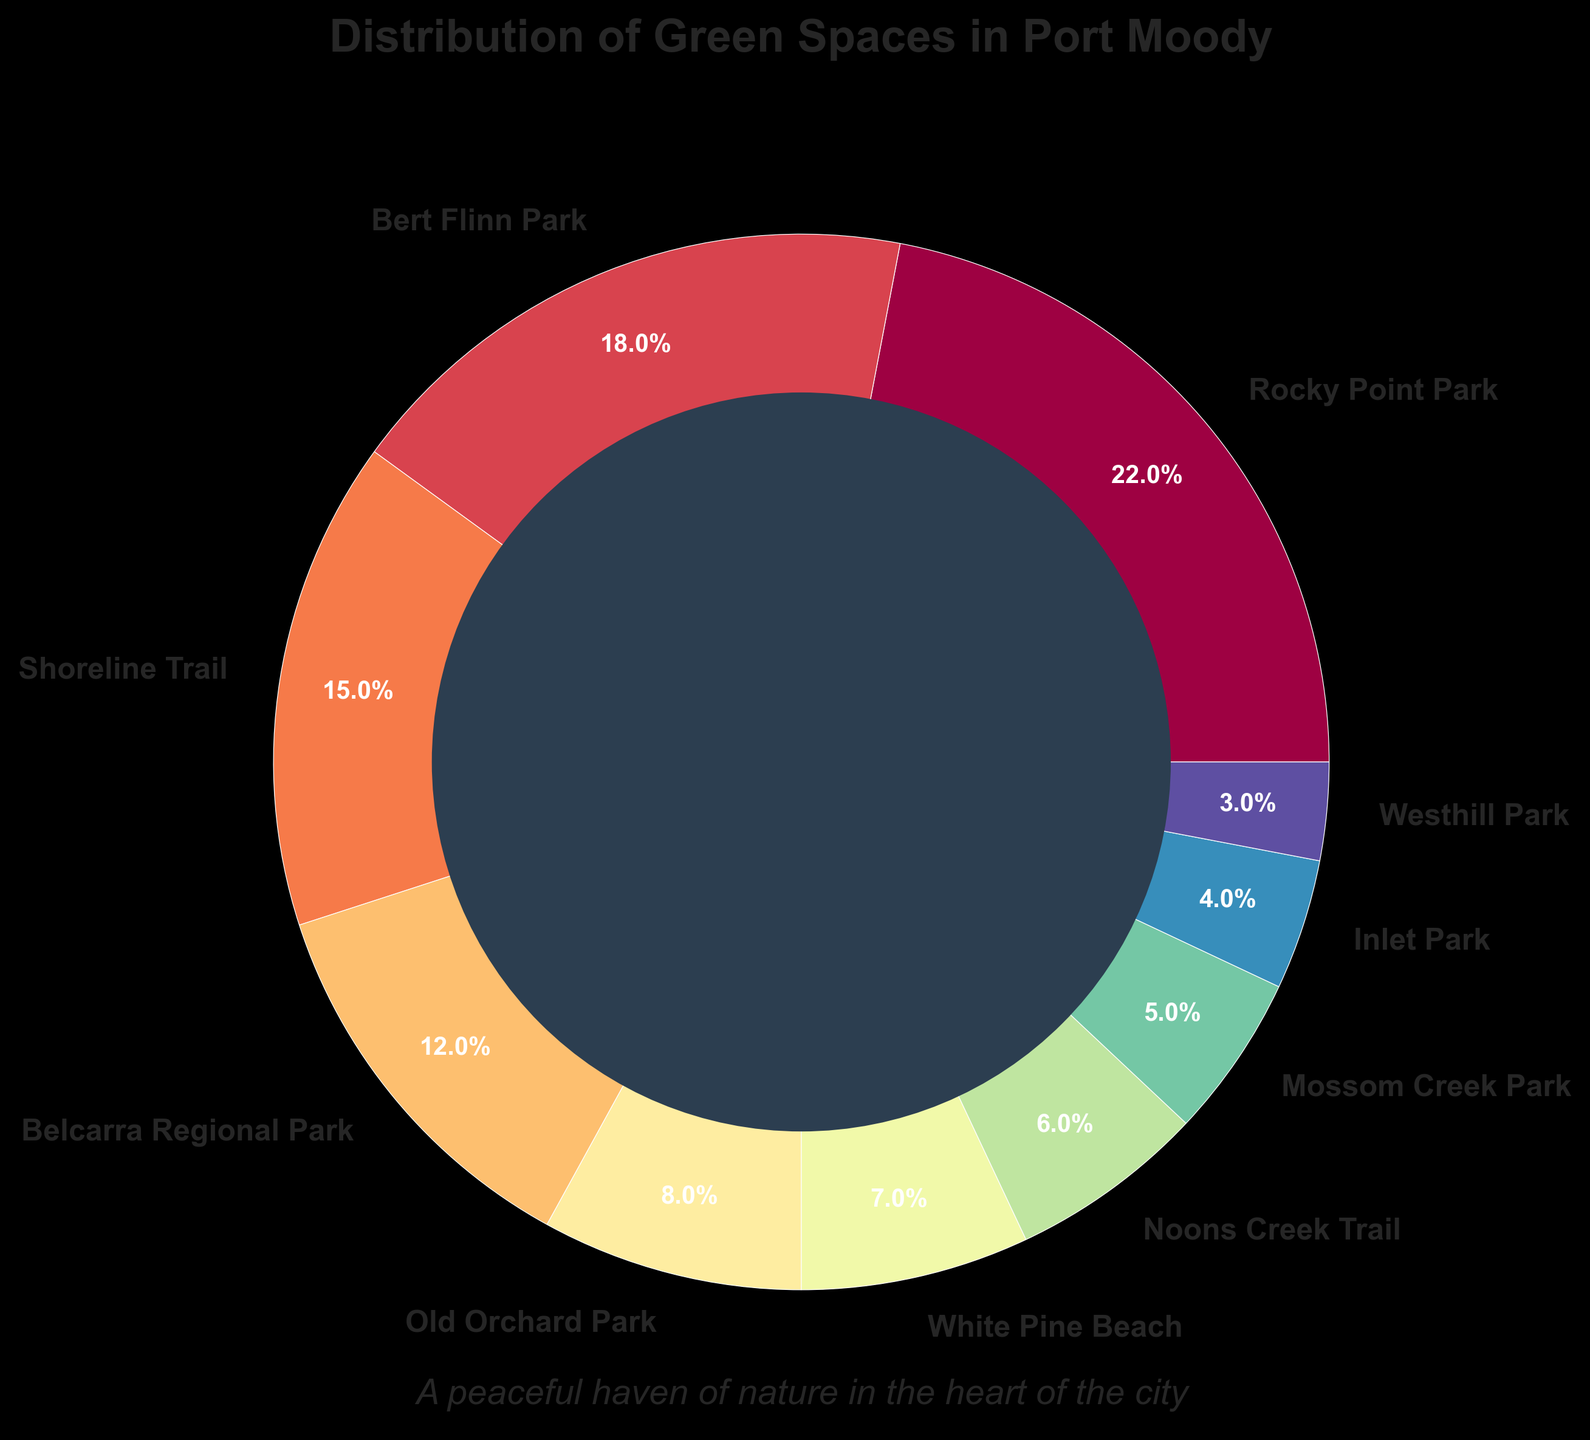Which green space occupies the largest portion of the pie chart? The largest segment in the pie chart corresponds to the category labeled "Rocky Point Park," which also has the highest percentage indicated in the chart.
Answer: Rocky Point Park Which green space has a smaller percentage, Noons Creek Trail or Mossom Creek Park? By comparing the "Noons Creek Trail" (6%) sector to the "Mossom Creek Park" (5%) sector, we see that Mossom Creek Park has the smaller percentage.
Answer: Mossom Creek Park What is the combined percentage of Rocky Point Park and Bert Flinn Park? The chart shows that Rocky Point Park has 22% and Bert Flinn Park has 18%. Adding these together: 22% + 18% = 40%.
Answer: 40% What is the approximate difference in percentage between the largest and smallest green spaces? The largest is Rocky Point Park with 22%, and the smallest is Westhill Park with 3%. The difference is 22% - 3% = 19%.
Answer: 19% Is Shoreline Trail larger or smaller than Old Orchard Park? Shoreline Trail is 15%, while Old Orchard Park is 8%, making Shoreline Trail larger.
Answer: Larger How many green spaces have a percentage greater than 10%? By observing the pie chart, we note that Rocky Point Park (22%), Bert Flinn Park (18%), Shoreline Trail (15%), and Belcarra Regional Park (12%) all have percentages greater than 10%. That totals to 4 green spaces.
Answer: 4 What's the total percentage of all trails represented in the chart? The trails mentioned are Shoreline Trail (15%) and Noons Creek Trail (6%). Adding these gives 15% + 6% = 21%.
Answer: 21% What is the mean percentage of conservation areas if they are identified as Belcarra Regional Park and Mossom Creek Park? Belcarra Regional Park is 12% and Mossom Creek Park is 5%. Adding these: 12% + 5% = 17% and dividing by 2 (the number of conservation areas): 17% / 2 = 8.5%.
Answer: 8.5% Between White Pine Beach and Inlet Park, which green space occupies a smaller portion? According to the pie chart, White Pine Beach is 7% and Inlet Park is 4%. Therefore, Inlet Park occupies a smaller portion.
Answer: Inlet Park 